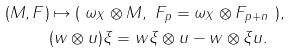Convert formula to latex. <formula><loc_0><loc_0><loc_500><loc_500>( M , F ) & \mapsto ( \ \omega _ { X } \otimes M , \ F _ { p } = \omega _ { X } \otimes F _ { p + n } \ ) , \\ & ( w \otimes u ) \xi = w \xi \otimes u - w \otimes \xi u .</formula> 